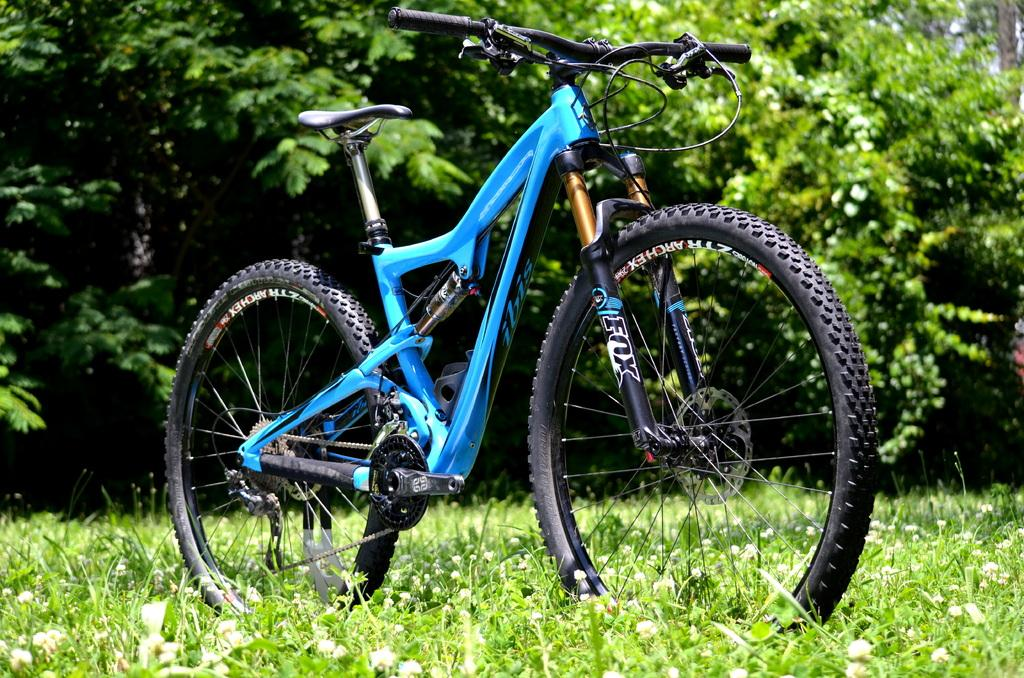What is the main subject of the image? There is a bicycle in the center of the image. Where is the bicycle located? The bicycle is on the grass. What can be seen in the background of the image? There are trees visible in the background of the image. How many spiders are crawling on the bicycle in the image? There are no spiders visible on the bicycle in the image. What type of juice is being served in the image? There is no juice present in the image; it features a bicycle on the grass with trees in the background. 